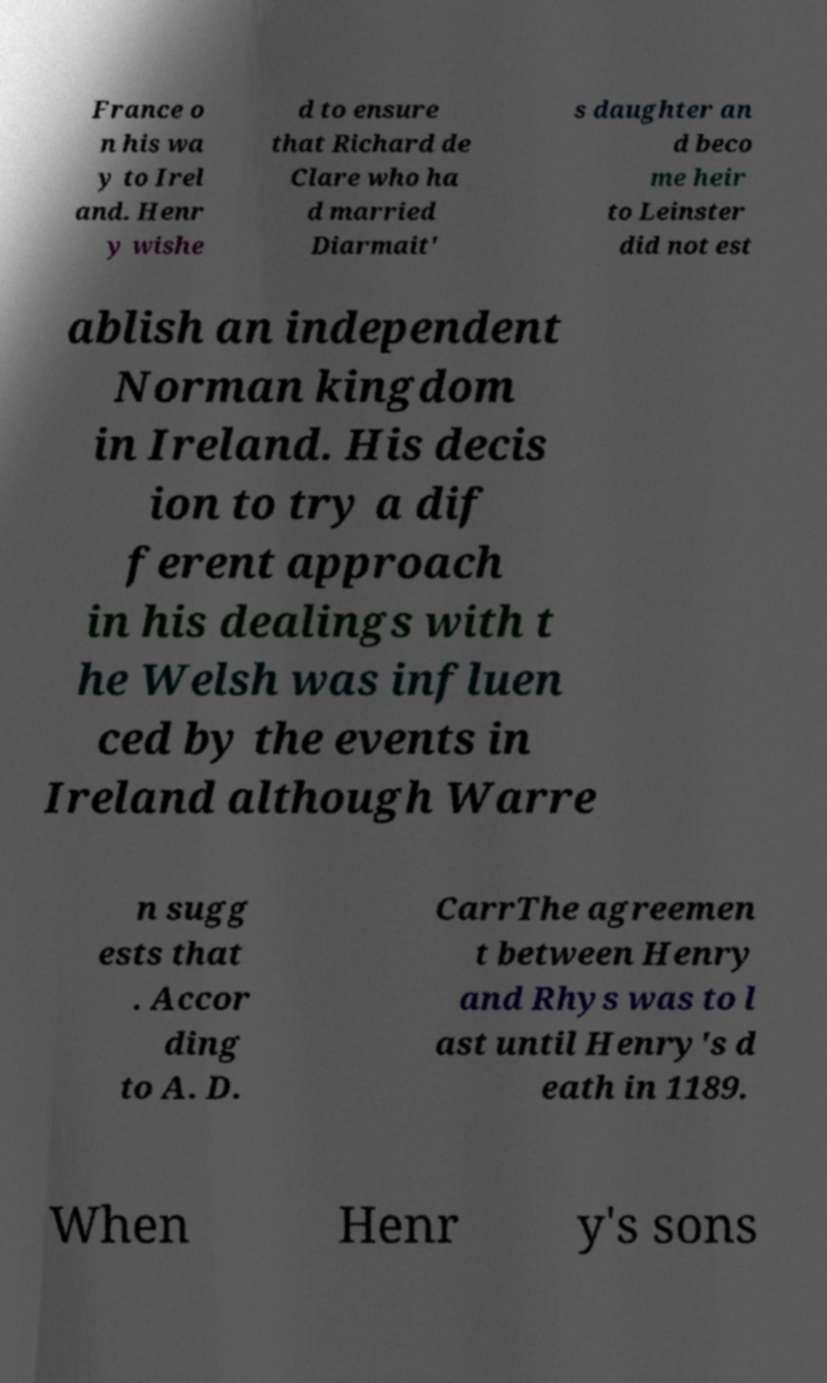Could you assist in decoding the text presented in this image and type it out clearly? France o n his wa y to Irel and. Henr y wishe d to ensure that Richard de Clare who ha d married Diarmait' s daughter an d beco me heir to Leinster did not est ablish an independent Norman kingdom in Ireland. His decis ion to try a dif ferent approach in his dealings with t he Welsh was influen ced by the events in Ireland although Warre n sugg ests that . Accor ding to A. D. CarrThe agreemen t between Henry and Rhys was to l ast until Henry's d eath in 1189. When Henr y's sons 